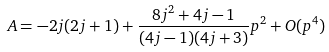Convert formula to latex. <formula><loc_0><loc_0><loc_500><loc_500>A = - 2 j ( 2 j + 1 ) + \frac { 8 j ^ { 2 } + 4 j - 1 } { ( 4 j - 1 ) ( 4 j + 3 ) } p ^ { 2 } + O ( p ^ { 4 } )</formula> 